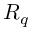Convert formula to latex. <formula><loc_0><loc_0><loc_500><loc_500>R _ { q }</formula> 